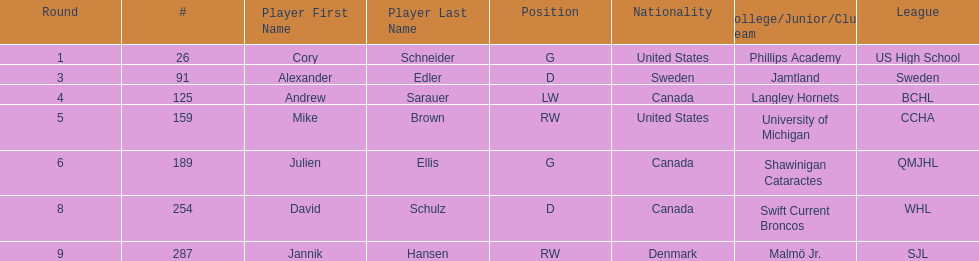List each player drafted from canada. Andrew Sarauer (LW), Julien Ellis (G), David Schulz (D). 